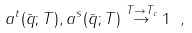<formula> <loc_0><loc_0><loc_500><loc_500>a ^ { t } ( \bar { q } ; T ) , a ^ { s } ( \bar { q } ; T ) \stackrel { T \to T _ { c } } { \to } 1 \ ,</formula> 